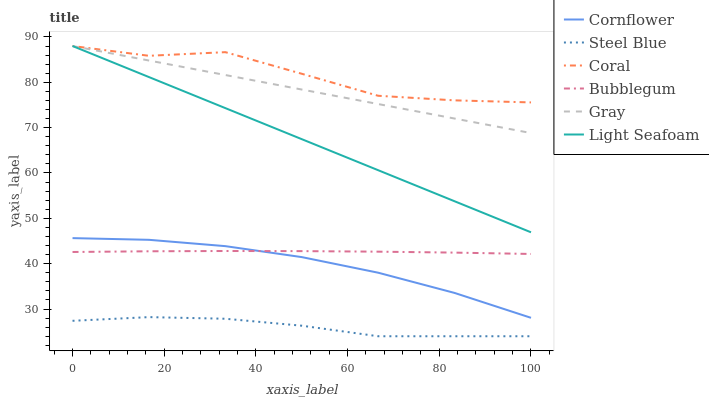Does Gray have the minimum area under the curve?
Answer yes or no. No. Does Gray have the maximum area under the curve?
Answer yes or no. No. Is Gray the smoothest?
Answer yes or no. No. Is Gray the roughest?
Answer yes or no. No. Does Gray have the lowest value?
Answer yes or no. No. Does Steel Blue have the highest value?
Answer yes or no. No. Is Cornflower less than Light Seafoam?
Answer yes or no. Yes. Is Coral greater than Steel Blue?
Answer yes or no. Yes. Does Cornflower intersect Light Seafoam?
Answer yes or no. No. 